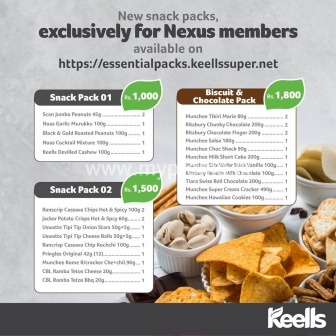Can you tell me more about the types of snacks included in each pack? Certainly! The advertisement showcases two different snack packs, each with a variety of enticing treats:

**Snack Pack 01** (priced at 1,000):
- San Juana Peanuts 45g
- San Carlo Potato Chips 70g
- Keells Salted Peanuts 75g
- ASDA Chocolate Wafers 150g
- Keells Grilled Cashew 150g

**Snack Pack 02** (priced at 1,500):
- Roscrip Cassava Chips 75g
- Ama's Sweet Chilli Chips 150g
- Burts Hand-Cooked Potato Chips 150g
- Walkers Sensations Poppadoms 69g
- Mister Potato BBQ Chips 160g
- Ritz Original Biscuits 200g
- Ferrero Rocher 30g
- M&M's Peanut Butter 34g
- Oreos Chocolate Sandwich Cookies 137g
- Cadbury Dairy Milk Fruit & Nut 100g Which of these snacks are included in the Biscuit & Chocolate Pack? The Biscuit & Chocolate Pack, priced at 1,800, includes the following:
- Nutella 15g
- Hershey Cookies & Cream 215g
- Maryland Cookies 180g
- Oreo Golden 154g
- Cadbury Choco Chip Cookies 175g
- Lotte Choco Pie 176g
- Meiji Hello Panda 205g
- Pepperidge Farm Milano 283g
- Chips Ahoy! Original 283g
- Lindt Chocolate Bar 150g
- Godiva Dark Chocolate 100g
- Keebler Fudge Stripes 214g
- Nabisco Ritz Crackers 200g Can you imagine a fun event where these snack packs would be perfect? Absolutely! Imagine a movie marathon night with friends. These snack packs would be perfect for such an occasion. You could have different snack stations set up for each pack. The guests could start with salty nuts and chips from Snack Pack 01 to keep the energy high, move on to the sweeter treats in Snack Pack 02 for an intermission snack, and enjoy the delectable biscuits and chocolates from the Biscuit & Chocolate Pack during the grand finale of the movie marathon. This variety ensures that there's something for everyone, making the event even more enjoyable! 